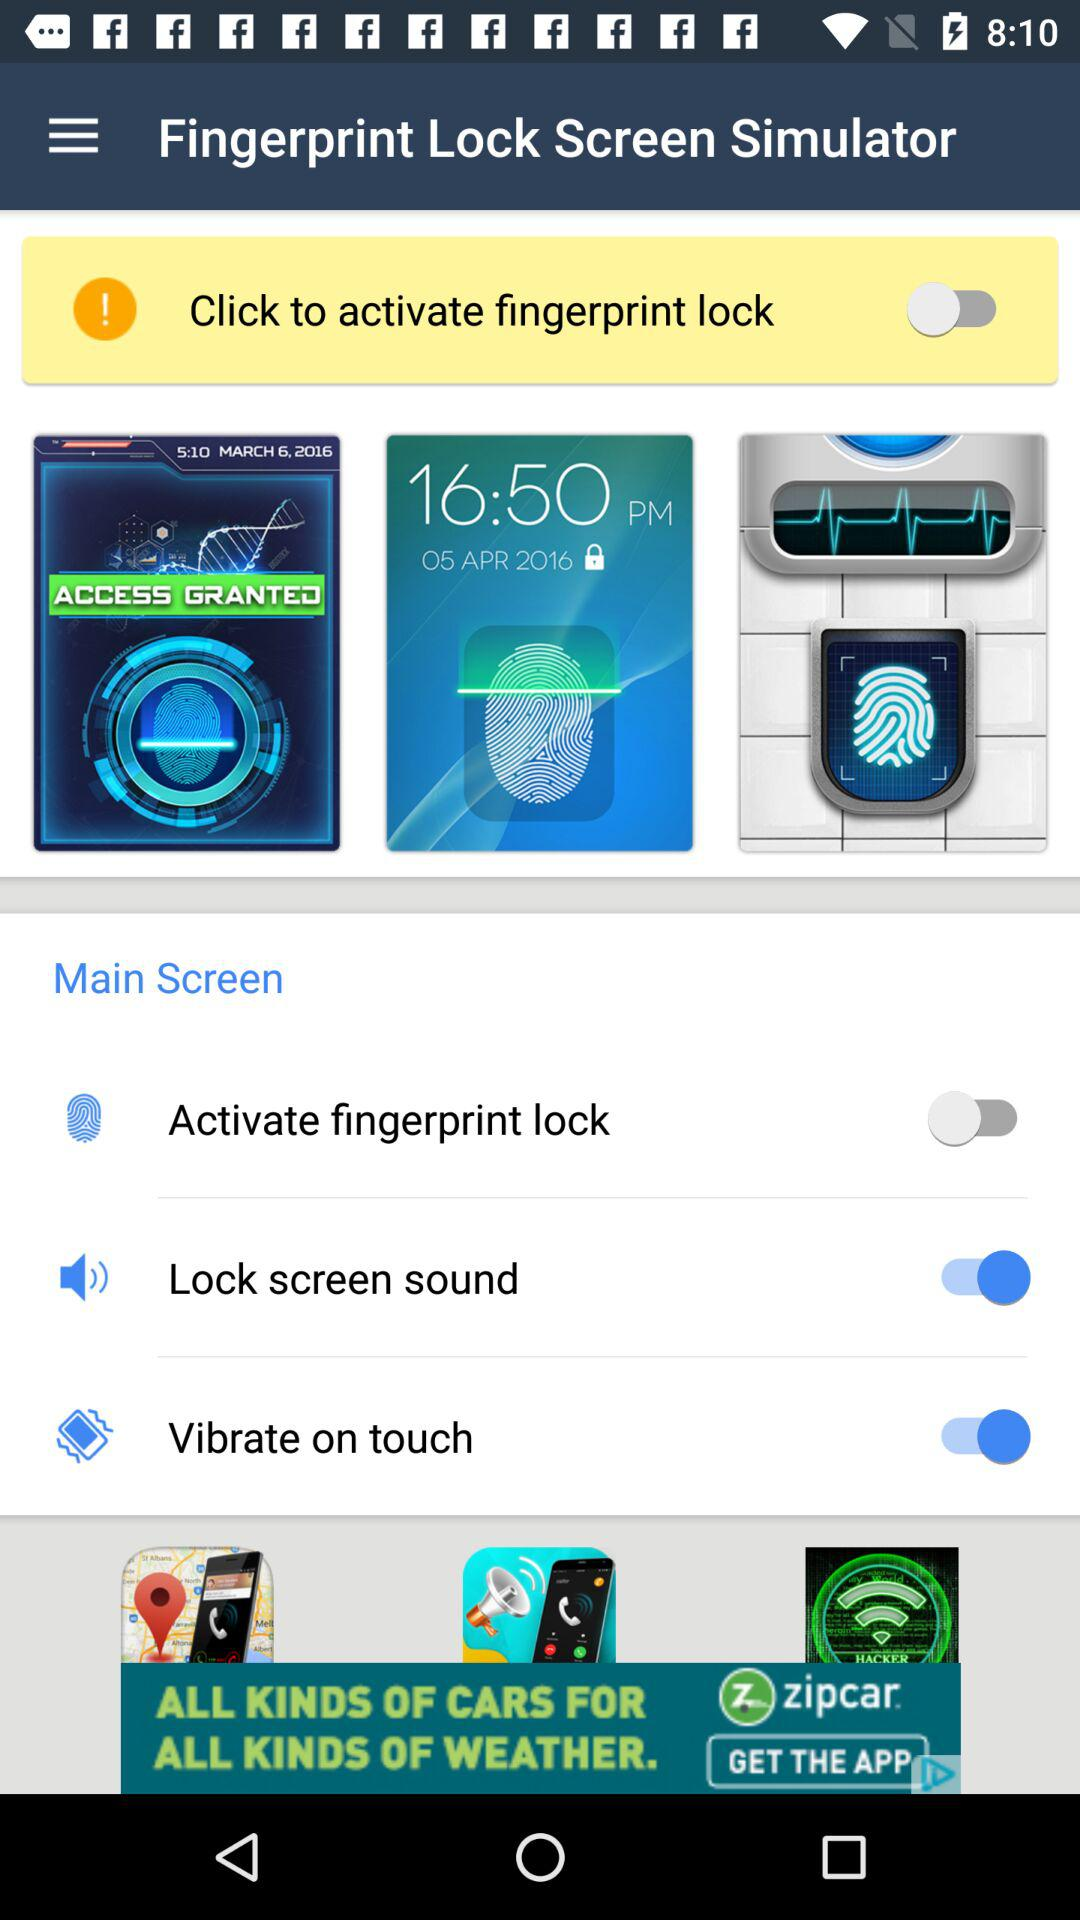What is the status of "Activate fingerprint lock"? The status is "off". 